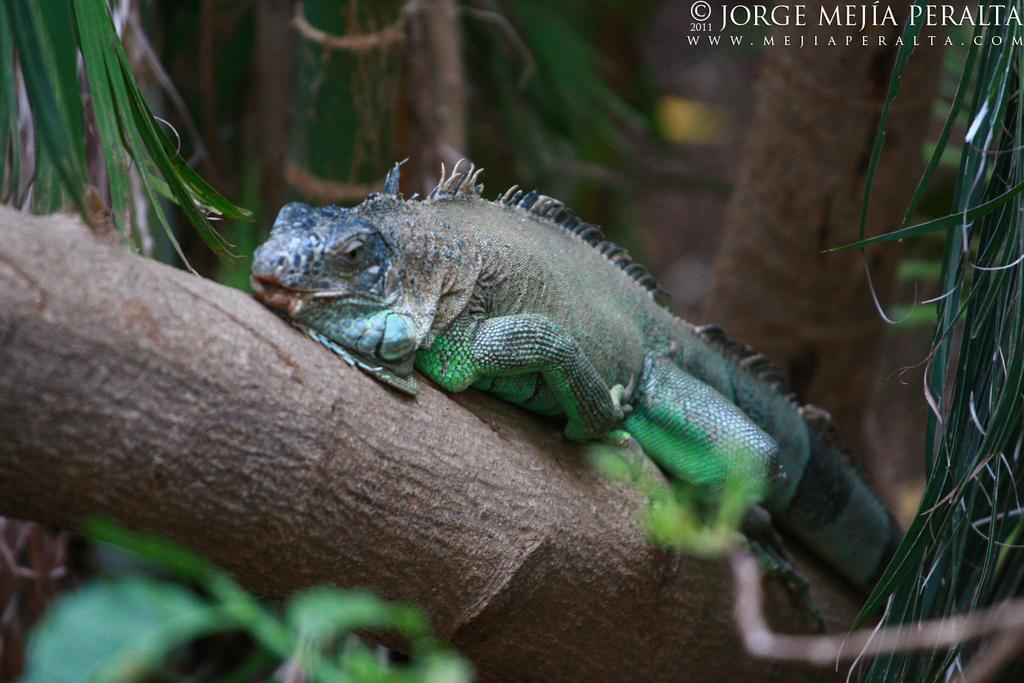What type of animal is in the image? There is an iguana in the image. Where is the iguana located? The iguana is on a branch. What can be seen in the background of the image? There are leaves in the image. Is there any text present in the image? Yes, there is some text in the top right corner of the image. Can you tell me how deep the quicksand is in the image? There is no quicksand present in the image; it features an iguana on a branch with leaves in the background and some text in the top right corner. 